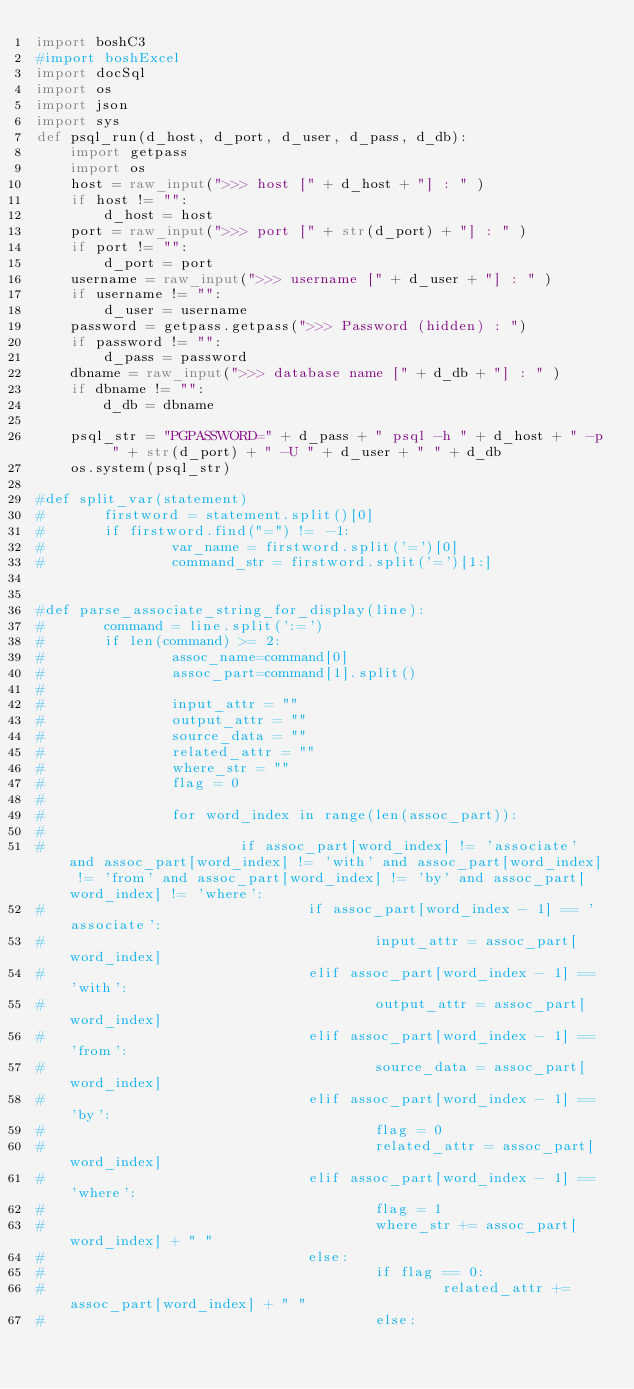<code> <loc_0><loc_0><loc_500><loc_500><_Python_>import boshC3
#import boshExcel
import docSql
import os
import json
import sys
def psql_run(d_host, d_port, d_user, d_pass, d_db):
    import getpass
    import os
    host = raw_input(">>> host [" + d_host + "] : " )
    if host != "":
        d_host = host
    port = raw_input(">>> port [" + str(d_port) + "] : " )
    if port != "":
        d_port = port
    username = raw_input(">>> username [" + d_user + "] : " )
    if username != "":
        d_user = username
    password = getpass.getpass(">>> Password (hidden) : ")
    if password != "":
        d_pass = password
    dbname = raw_input(">>> database name [" + d_db + "] : " )
    if dbname != "":
        d_db = dbname

    psql_str = "PGPASSWORD=" + d_pass + " psql -h " + d_host + " -p " + str(d_port) + " -U " + d_user + " " + d_db
    os.system(psql_str)

#def split_var(statement)
#       firstword = statement.split()[0]
#       if firstword.find("=") != -1:
#               var_name = firstword.split('=')[0]
#               command_str = firstword.split('=')[1:]


#def parse_associate_string_for_display(line):
#       command = line.split(':=')
#       if len(command) >= 2:
#               assoc_name=command[0]
#               assoc_part=command[1].split()
#
#               input_attr = ""
#               output_attr = ""
#               source_data = ""
#               related_attr = ""
#               where_str = ""
#               flag = 0
#
#               for word_index in range(len(assoc_part)):
#
#                       if assoc_part[word_index] != 'associate' and assoc_part[word_index] != 'with' and assoc_part[word_index] != 'from' and assoc_part[word_index] != 'by' and assoc_part[word_index] != 'where':
#                               if assoc_part[word_index - 1] == 'associate':
#                                       input_attr = assoc_part[word_index]
#                               elif assoc_part[word_index - 1] == 'with':
#                                       output_attr = assoc_part[word_index]
#                               elif assoc_part[word_index - 1] == 'from':
#                                       source_data = assoc_part[word_index]
#                               elif assoc_part[word_index - 1] == 'by':
#                                       flag = 0
#                                       related_attr = assoc_part[word_index]
#                               elif assoc_part[word_index - 1] == 'where':
#                                       flag = 1
#                                       where_str += assoc_part[word_index] + " "
#                               else:
#                                       if flag == 0:
#                                               related_attr += assoc_part[word_index] + " "
#                                       else:</code> 